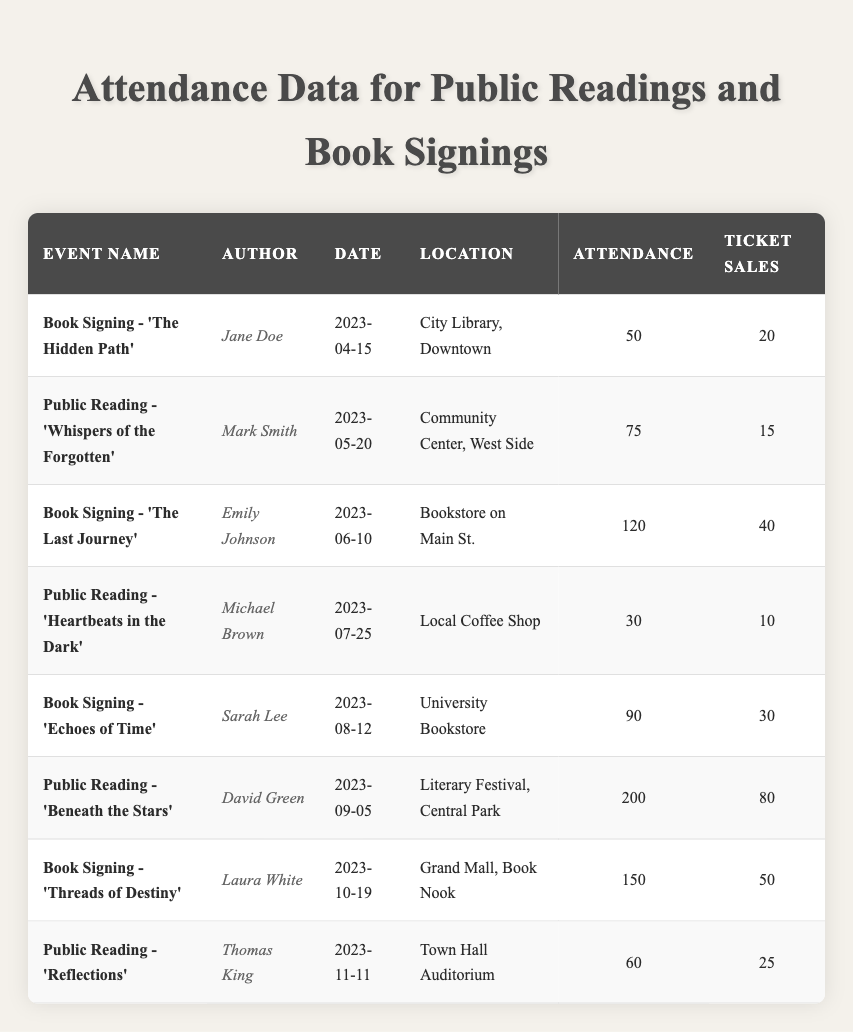What is the attendance for the event "Public Reading - 'Beneath the Stars'"? The attendance figure for that specific event is directly listed in the table under the "Attendance" column for the event. Looking at the row for "Public Reading - 'Beneath the Stars'", it states that the attendance is 200.
Answer: 200 What is the date of the event "Book Signing - 'Threads of Destiny'"? The date for that event is provided in the table under the "Date" column for that specific event. The row shows that the date is October 19, 2023.
Answer: October 19, 2023 Which event had the highest ticket sales? By comparing the values under the "Ticket Sales" column, we can see that the event with the highest ticket sales will have the largest number. Here, the event "Public Reading - 'Beneath the Stars'" has the highest ticket sales of 80.
Answer: Public Reading - 'Beneath the Stars' How many total ticket sales were generated from all the events combined? First, we need to sum the ticket sales from each row in the "Ticket Sales" column. Adding the numbers (20 + 15 + 40 + 10 + 30 + 80 + 50 + 25) gives a total of 270.
Answer: 270 Is there an event with more than 100 attendees? To determine this, we check the "Attendance" column for any values exceeding 100. The events "The Last Journey", "Beneath the Stars", and "Threads of Destiny" all have attendance counts of 120, 200, and 150 respectively, thus confirming that there are indeed events with more than 100 attendees.
Answer: Yes What are the average ticket sales for all public readings? First, we locate the public reading events: "Whispers of the Forgotten", "Heartbeats in the Dark", "Beneath the Stars", and "Reflections". Their ticket sales are 15, 10, 80, and 25 respectively. Summing these gives (15 + 10 + 80 + 25) = 130, and dividing by the number of events (4) results in an average of 32.5.
Answer: 32.5 Which author had the event with the lowest attendance? We look for the lowest number in the "Attendance" column and compare it with the corresponding author. The lowest attendance is 30 for the event "Public Reading - 'Heartbeats in the Dark'", authored by Michael Brown.
Answer: Michael Brown How many events took place in July 2023? We review the "Date" column to find events occurring in July 2023. There is only one event that takes place in July, which is "Public Reading - 'Heartbeats in the Dark'" on July 25, 2023.
Answer: 1 What was the total attendance for book signings? Identifying the book signing events ("The Hidden Path", "The Last Journey", "Echoes of Time", and "Threads of Destiny"), we find their attendance figures: 50, 120, 90, and 150. Adding these together gives (50 + 120 + 90 + 150) = 410 for total attendance at these events.
Answer: 410 Did any event held at a "Community Center" have more than 50 attendees? Checking the attendance for the "Public Reading - 'Whispers of the Forgotten'" held at the Community Center, it shows 75 attendees, which is more than 50, confirming the answer.
Answer: Yes 